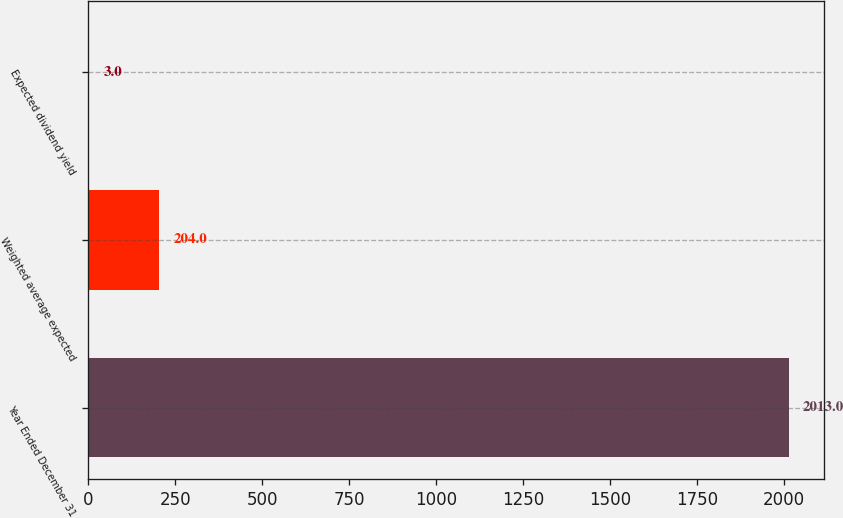Convert chart. <chart><loc_0><loc_0><loc_500><loc_500><bar_chart><fcel>Year Ended December 31<fcel>Weighted average expected<fcel>Expected dividend yield<nl><fcel>2013<fcel>204<fcel>3<nl></chart> 